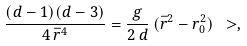Convert formula to latex. <formula><loc_0><loc_0><loc_500><loc_500>\frac { ( d - 1 ) ( d - 3 ) } { 4 \, \bar { r } ^ { 4 } } = \frac { g } { 2 \, d } \, ( \bar { r } ^ { 2 } - r _ { 0 } ^ { 2 } ) \ > ,</formula> 